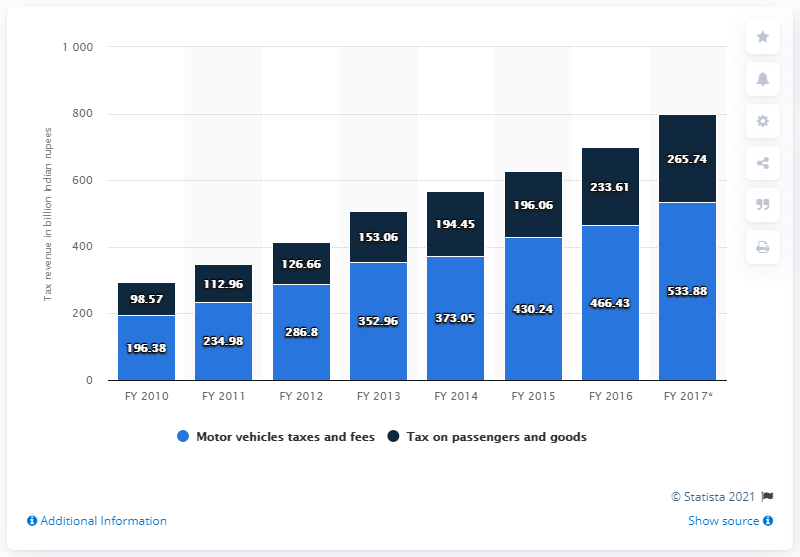Outline some significant characteristics in this image. In the fiscal year 2016, the state governments collected a total of 233.61 Indian rupees. 